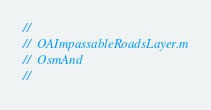<code> <loc_0><loc_0><loc_500><loc_500><_ObjectiveC_>//
//  OAImpassableRoadsLayer.m
//  OsmAnd
//</code> 